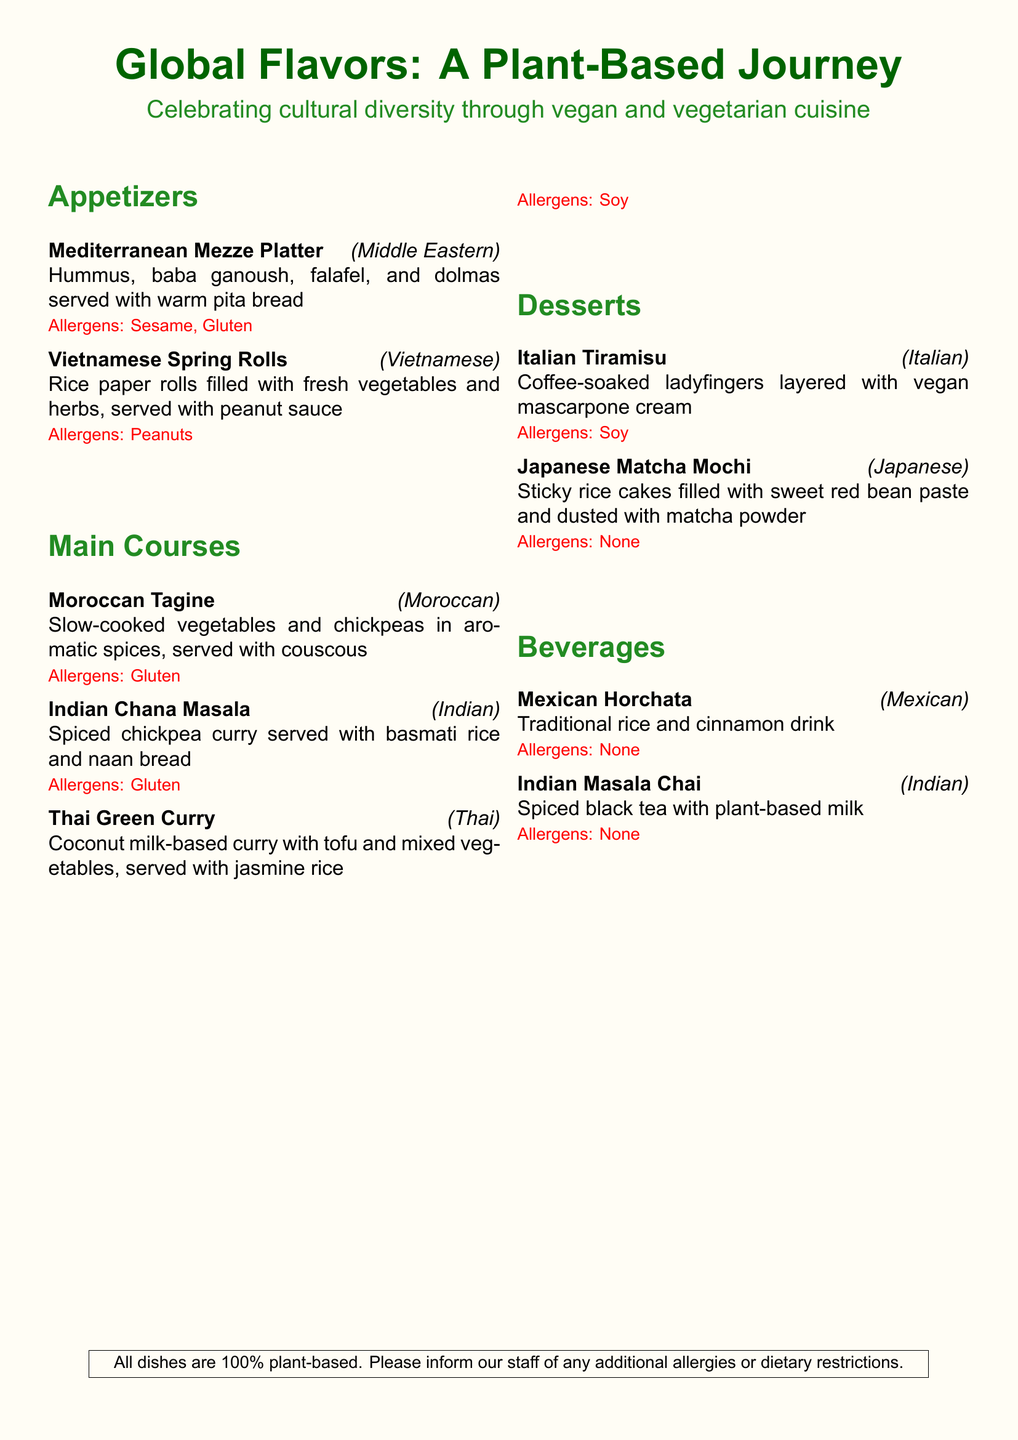What type of cuisine does the "Moroccan Tagine" represent? The cuisine is indicated in the menu item's description as "Moroccan."
Answer: Moroccan How many desserts are listed on the menu? The total number of desserts can be counted from the menu, which lists two items: Italian Tiramisu and Japanese Matcha Mochi.
Answer: 2 What is the main ingredient in the "Vietnamese Spring Rolls"? The description mentions that they are filled with "fresh vegetables and herbs."
Answer: vegetables Which dish contains peanuts? The menu specifically states that the "Vietnamese Spring Rolls" are served with peanut sauce, indicating they contain peanuts.
Answer: Vietnamese Spring Rolls What type of beverage is described as a traditional Mexican drink? The beverage listed under beverages identifies "Mexican Horchata" as traditional.
Answer: Mexican Horchata Which dish is spiced and served with basmati rice? The "Indian Chana Masala" is described as spiced and served with basmati rice.
Answer: Indian Chana Masala What is the allergen for the "Italian Tiramisu"? The menu notes that the allergen present in "Italian Tiramisu" is "Soy."
Answer: Soy Is any dish labeled as containing "Gluten"? The menu item "Moroccan Tagine" states that it contains gluten as an allergen.
Answer: Yes 